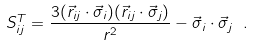Convert formula to latex. <formula><loc_0><loc_0><loc_500><loc_500>S _ { i j } ^ { T } = \frac { 3 ( \vec { r } _ { i j } \cdot \vec { \sigma } _ { i } ) ( \vec { r } _ { i j } \cdot \vec { \sigma } _ { j } ) } { r ^ { 2 } } - \vec { \sigma } _ { i } \cdot \vec { \sigma } _ { j } \ .</formula> 